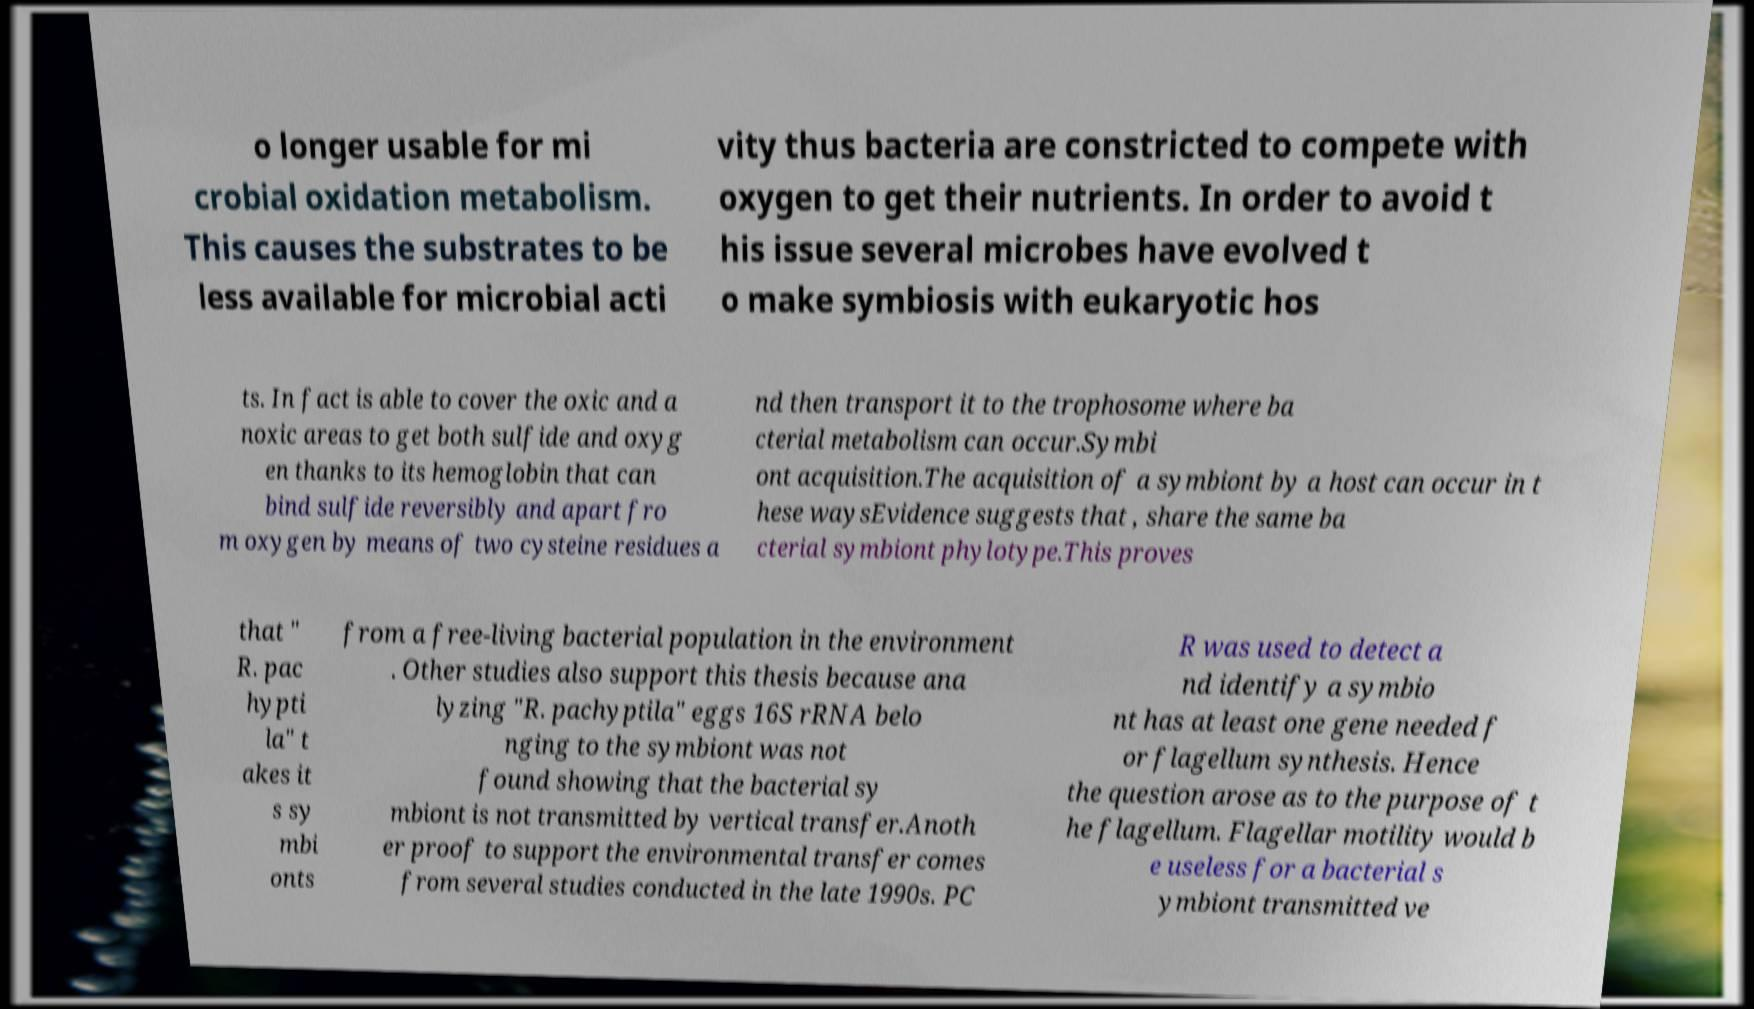Can you read and provide the text displayed in the image?This photo seems to have some interesting text. Can you extract and type it out for me? o longer usable for mi crobial oxidation metabolism. This causes the substrates to be less available for microbial acti vity thus bacteria are constricted to compete with oxygen to get their nutrients. In order to avoid t his issue several microbes have evolved t o make symbiosis with eukaryotic hos ts. In fact is able to cover the oxic and a noxic areas to get both sulfide and oxyg en thanks to its hemoglobin that can bind sulfide reversibly and apart fro m oxygen by means of two cysteine residues a nd then transport it to the trophosome where ba cterial metabolism can occur.Symbi ont acquisition.The acquisition of a symbiont by a host can occur in t hese waysEvidence suggests that , share the same ba cterial symbiont phylotype.This proves that " R. pac hypti la" t akes it s sy mbi onts from a free-living bacterial population in the environment . Other studies also support this thesis because ana lyzing "R. pachyptila" eggs 16S rRNA belo nging to the symbiont was not found showing that the bacterial sy mbiont is not transmitted by vertical transfer.Anoth er proof to support the environmental transfer comes from several studies conducted in the late 1990s. PC R was used to detect a nd identify a symbio nt has at least one gene needed f or flagellum synthesis. Hence the question arose as to the purpose of t he flagellum. Flagellar motility would b e useless for a bacterial s ymbiont transmitted ve 